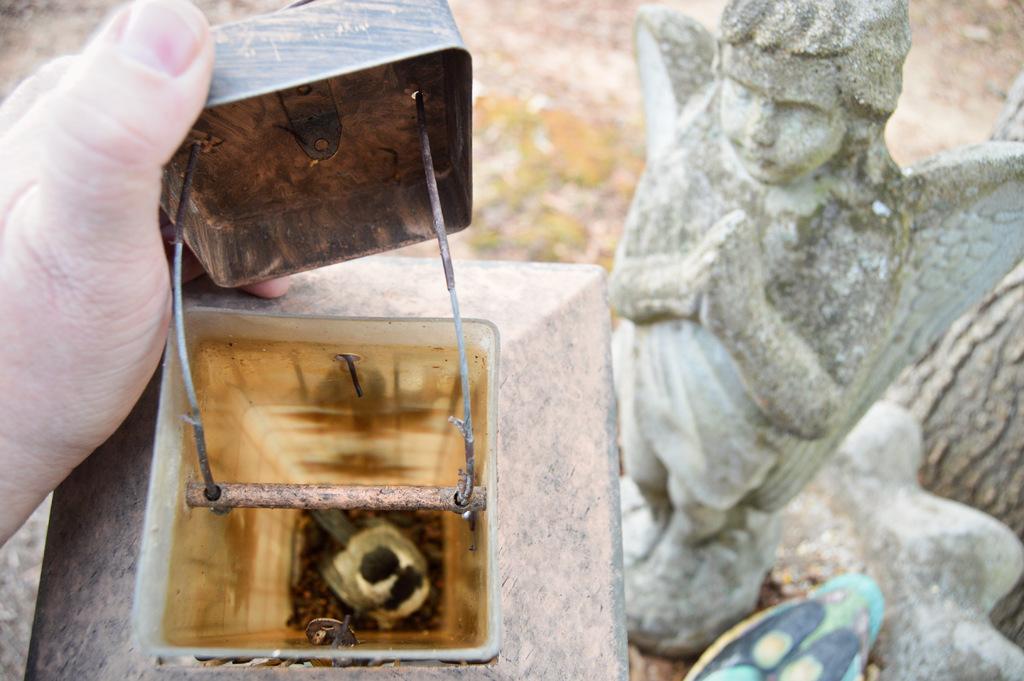In one or two sentences, can you explain what this image depicts? In the center of the image we can see a container on a stone. On the right side of the image there is a statue. On the left side we can see human hand. In the background there is a ground. 